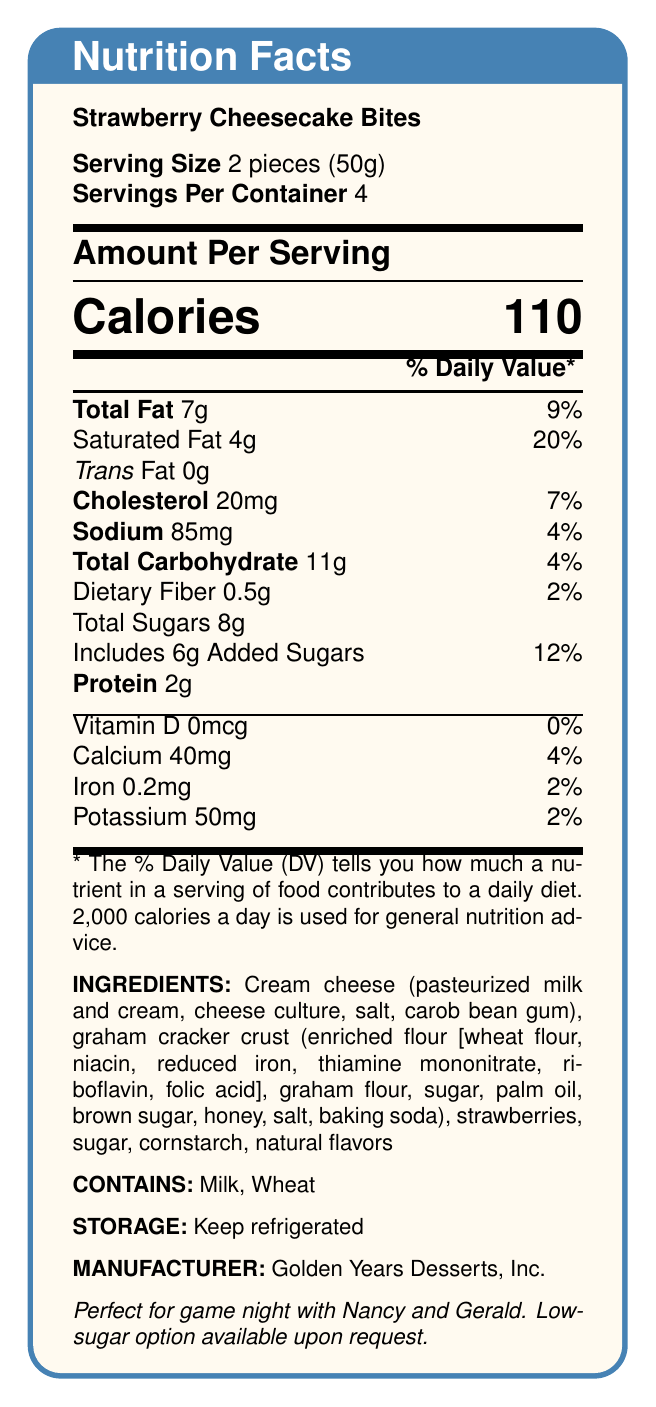what is the serving size of the dessert? The document states the serving size as 2 pieces (50g).
Answer: 2 pieces (50g) how many servings are in one container? The document mentions that there are 4 servings per container.
Answer: 4 how many calories are in one serving? Under the large heading of amount per serving, it lists 110 calories.
Answer: 110 calories how much total fat is in a single serving? The document notes that the total fat per serving is 7g.
Answer: 7g which company manufactures these Strawberry Cheesecake Bites? At the bottom of the document, it specifies that Golden Years Desserts, Inc. is the manufacturer.
Answer: Golden Years Desserts, Inc. what percentage of the daily value of saturated fat does one serving contain? The document indicates that one serving has 20% of the daily value of saturated fat.
Answer: 20% does this dessert contain any trans fat? The document shows that the trans fat content is 0g.
Answer: No what allergens are present in this dessert? The document lists the allergens as milk and wheat.
Answer: Milk, Wheat how much protein is in a serving? The document states that there are 2g of protein per serving.
Answer: 2g what is the sodium content in one serving? A. 85mg B. 90mg C. 100mg D. 120mg The document specifies that the sodium content in one serving is 85mg.
Answer: A. 85mg what is the daily value percentage of iron per serving? A. 2% B. 4% C. 6% D. 8% The document shows that the daily value percentage of iron per serving is 2%.
Answer: A. 2% are these cheesecake bites suitable for people with gluten sensitivity? The document lists wheat as one of the allergens, meaning these are not suitable for people with gluten sensitivity.
Answer: No summarize the main nutritional information of these cheesecake bites. The main nutritional information includes details about calories, fats, cholesterol, sodium, carbohydrates, dietary fiber, sugars, protein, and allergens, along with the instructions for storage and the manufacturer's information.
Answer: These Strawberry Cheesecake Bites have a serving size of 2 pieces (50g) with 4 servings per container. Each serving contains 110 calories, 7g of total fat (9% DV), 4g of saturated fat (20% DV), 0g trans fat, 20mg cholesterol (7% DV), 85mg sodium (4% DV), 11g of carbohydrates (4% DV), 0.5g dietary fiber (2% DV), 8g total sugars with 6g added sugars (12% DV), and 2g protein. It contains milk and wheat allergens and should be kept refrigerated. is there a low-sugar option available for these cheesecake bites? The document mentions a "Low-sugar option available upon request."
Answer: Yes what is the main sweetener used in these cheesecake bites? The document lists multiple potential sweetening ingredients like sugar, brown sugar, and honey without specifying which is the main sweetener.
Answer: Cannot be determined 